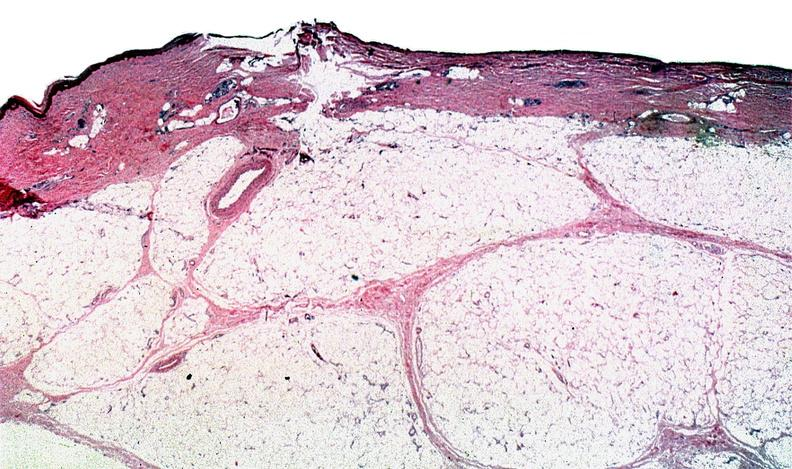what does this image show?
Answer the question using a single word or phrase. Thermal burned skin 